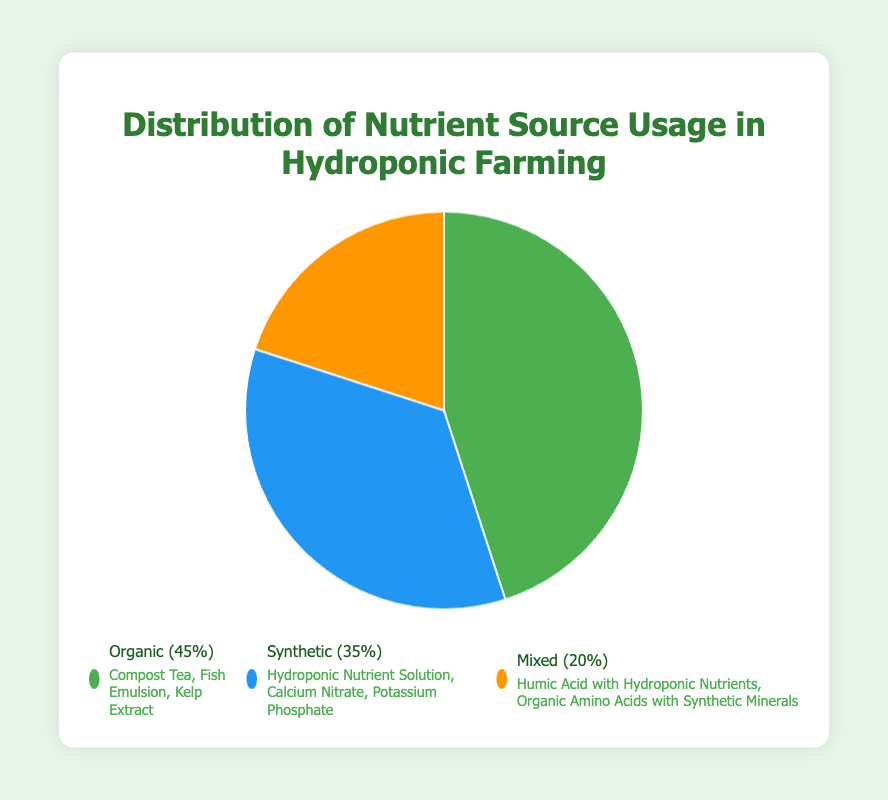What percentage of the nutrient sources used is Organic? By looking at the pie chart, the segment labeled "Organic" indicates the percentage of its usage.
Answer: 45% How much higher is the usage of Organic nutrients compared to Mixed nutrients? The percentage of Organic nutrients is 45%, while the percentage of Mixed nutrients is 20%. The difference between them is 45% - 20%.
Answer: 25% Which nutrient source has the lowest usage percentage? By observing the pie chart, the segment with the smallest arc represents the least usage, in this case, "Mixed" nutrients.
Answer: Mixed What is the total percentage of Synthetic and Mixed nutrient usage combined? The percentage of Synthetic nutrients is 35%, and the percentage of Mixed nutrients is 20%. Adding these together gives 35% + 20%.
Answer: 55% Which nutrient source type is represented by the color green? The color green in the pie chart corresponds to the nutrient source labeled "Organic".
Answer: Organic How much more common are Organic nutrient sources compared to Synthetic nutrient sources? The percentage of Organic nutrients is 45%, and the percentage of Synthetic nutrients is 35%. The difference is 45% - 35%.
Answer: 10% What are some examples of Mixed nutrient sources listed in the chart? The section labeled "Mixed" provides examples such as Humic Acid with Hydroponic Nutrients and Organic Amino Acids with Synthetic Minerals.
Answer: Humic Acid with Hydroponic Nutrients, Organic Amino Acids with Synthetic Minerals What are the three nutrient source types shown in the pie chart? The pie chart is divided into segments labeled Organic, Synthetic, and Mixed.
Answer: Organic, Synthetic, Mixed What percentage of nutrient source usage is not Organic? The percentage of Organic nutrient usage is 45%. Subtract this from 100% to find the percentage that is not Organic: 100% - 45%.
Answer: 55% How do the percentages of Organic and Synthetic nutrient sources compare? The percentage of Organic nutrients is 45%, while the percentage of Synthetic nutrients is 35%. Organic is 10% higher than Synthetic.
Answer: Organic is 10% higher than Synthetic 